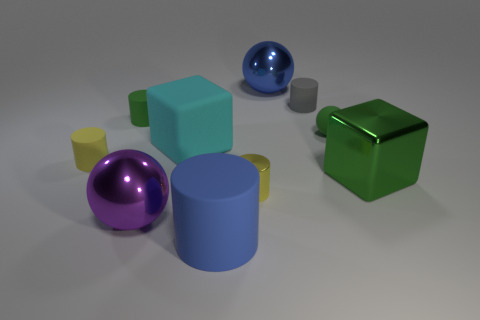What is the material of the large green object that is in front of the small green matte ball?
Offer a very short reply. Metal. How many cyan objects are either small things or tiny matte things?
Give a very brief answer. 0. Do the big green object and the big thing that is in front of the big purple metal thing have the same material?
Your answer should be compact. No. Are there an equal number of tiny shiny things left of the large cyan rubber block and green objects left of the green cylinder?
Ensure brevity in your answer.  Yes. Is the size of the gray thing the same as the matte thing in front of the big purple metallic ball?
Keep it short and to the point. No. Is the number of big green objects that are to the left of the gray object greater than the number of matte cylinders?
Offer a very short reply. No. What number of green cylinders are the same size as the cyan block?
Your answer should be compact. 0. There is a green rubber thing that is left of the large blue matte object; does it have the same size as the ball to the left of the big blue rubber object?
Your response must be concise. No. Is the number of big blue matte things that are behind the big rubber block greater than the number of metallic things right of the small gray rubber cylinder?
Provide a succinct answer. No. How many large blue things are the same shape as the purple shiny thing?
Make the answer very short. 1. 